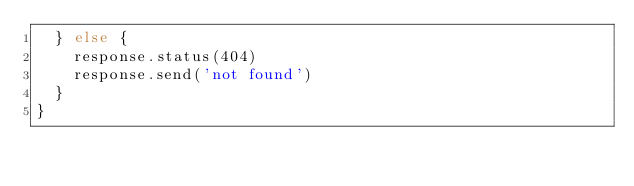Convert code to text. <code><loc_0><loc_0><loc_500><loc_500><_JavaScript_>  } else {
    response.status(404)
    response.send('not found')
  }
}
</code> 